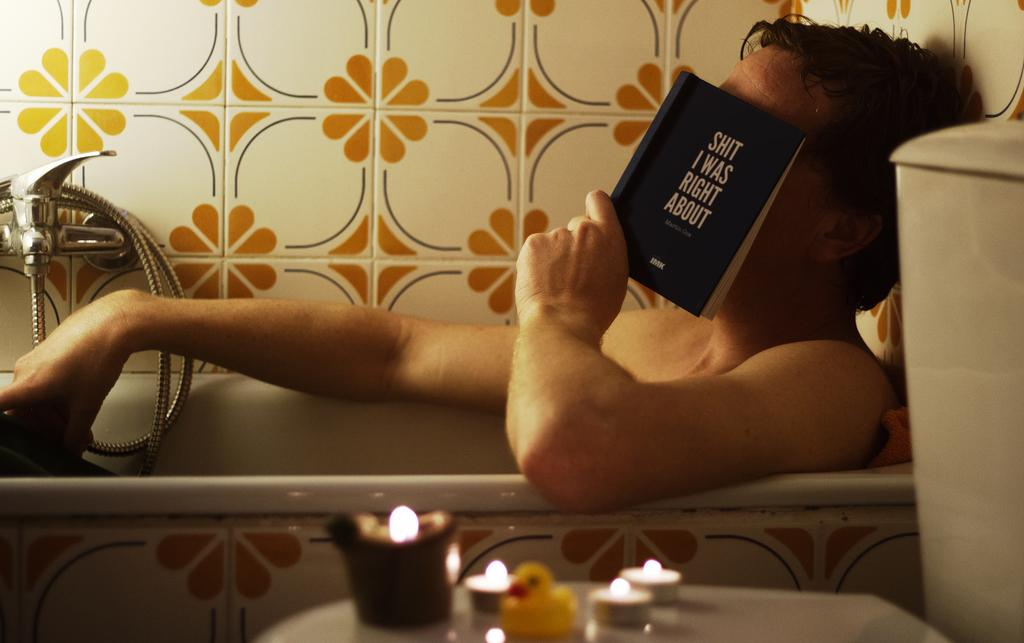<image>
Offer a succinct explanation of the picture presented. A man sitting in a bath tub reading a copy of the book "s*it i was right about". 